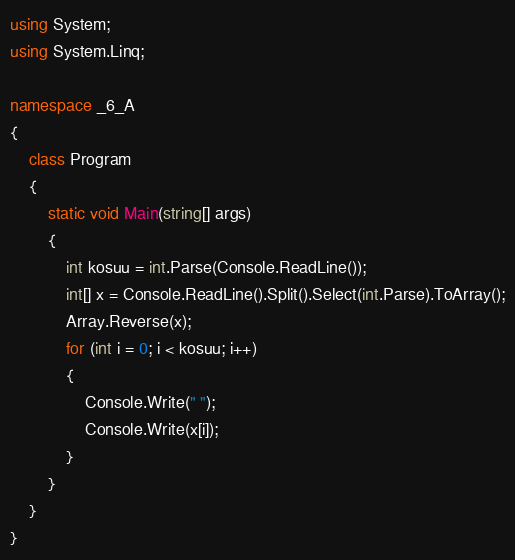Convert code to text. <code><loc_0><loc_0><loc_500><loc_500><_C#_>using System;
using System.Linq;

namespace _6_A
{
    class Program
    {
        static void Main(string[] args)
        {
            int kosuu = int.Parse(Console.ReadLine());
            int[] x = Console.ReadLine().Split().Select(int.Parse).ToArray();
            Array.Reverse(x);
            for (int i = 0; i < kosuu; i++)
            {
                Console.Write(" ");
                Console.Write(x[i]);
            }
        }
    }
}</code> 